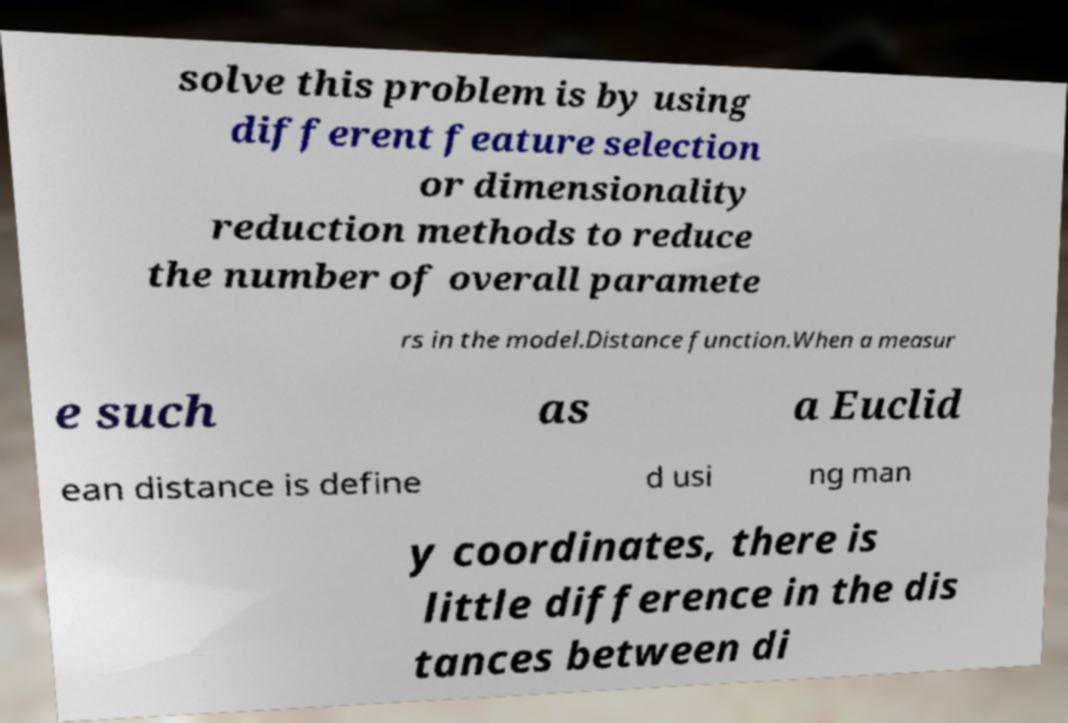Please identify and transcribe the text found in this image. solve this problem is by using different feature selection or dimensionality reduction methods to reduce the number of overall paramete rs in the model.Distance function.When a measur e such as a Euclid ean distance is define d usi ng man y coordinates, there is little difference in the dis tances between di 